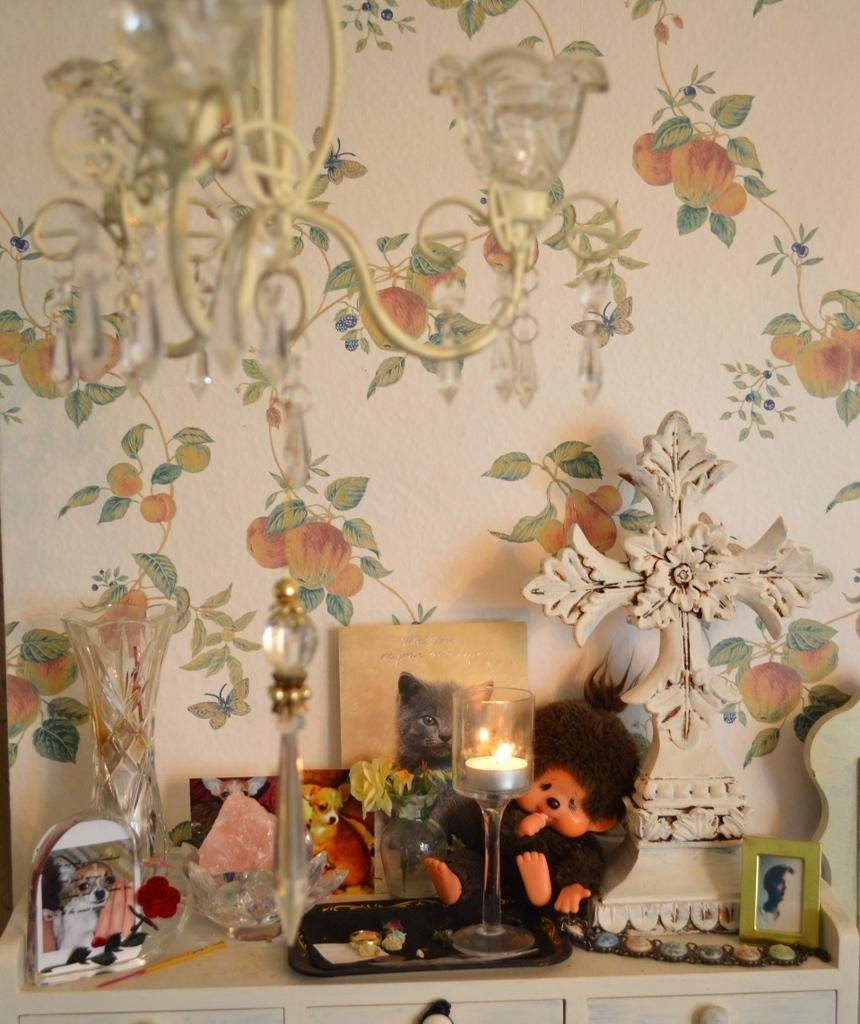What is the main piece of furniture in the image? There is a table in the image. What items can be seen on the table? There are toys and a candle on the table. What can be seen in the background of the image? There is a wall in the background of the image. What type of lighting fixture is visible at the top of the image? There is a chandelier at the top of the image. How many cherries are in the pocket of the person in the image? There is no person present in the image, and therefore no pockets or cherries can be observed. 